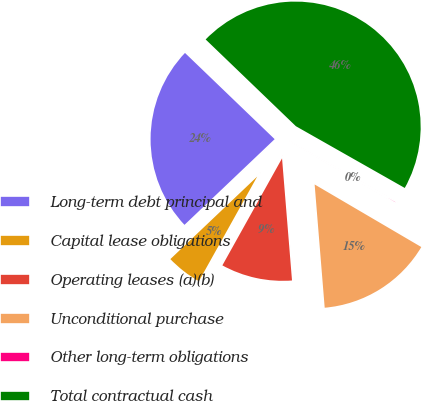<chart> <loc_0><loc_0><loc_500><loc_500><pie_chart><fcel>Long-term debt principal and<fcel>Capital lease obligations<fcel>Operating leases (a)(b)<fcel>Unconditional purchase<fcel>Other long-term obligations<fcel>Total contractual cash<nl><fcel>24.28%<fcel>4.81%<fcel>9.39%<fcel>15.26%<fcel>0.23%<fcel>46.02%<nl></chart> 